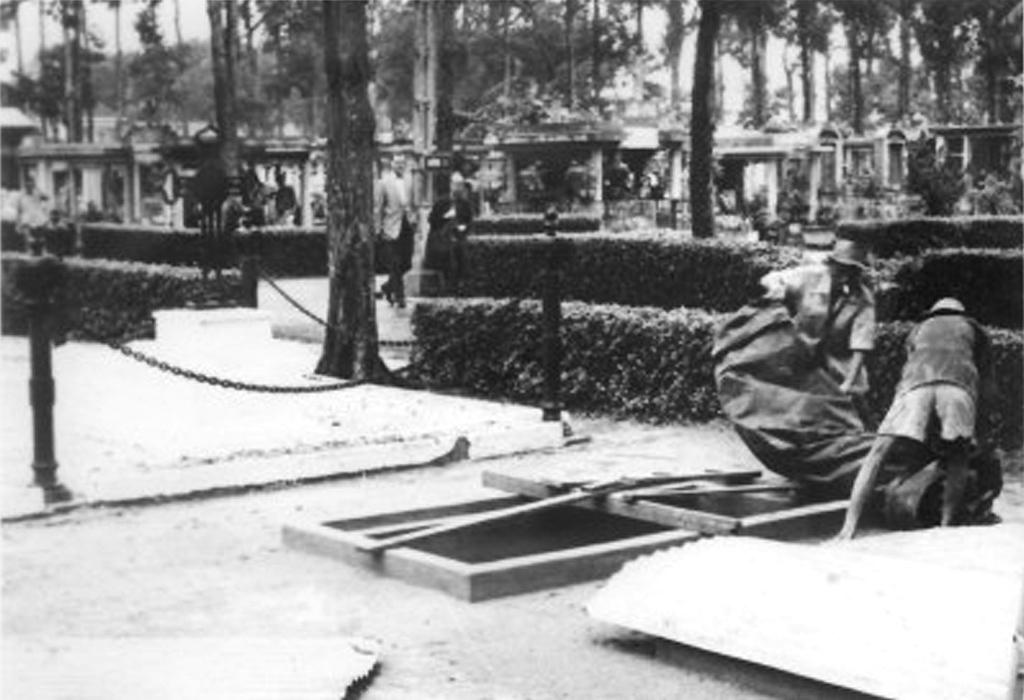What can be seen in the image? There are people standing in the image. What objects are present in the image? There are poles, trees, chains, and bushes in the image. What is the color scheme of the image? The image is black and white in color. What type of calendar is hanging on the wall in the image? There is no calendar present in the image; it is a black and white image with people, poles, trees, chains, and bushes. 